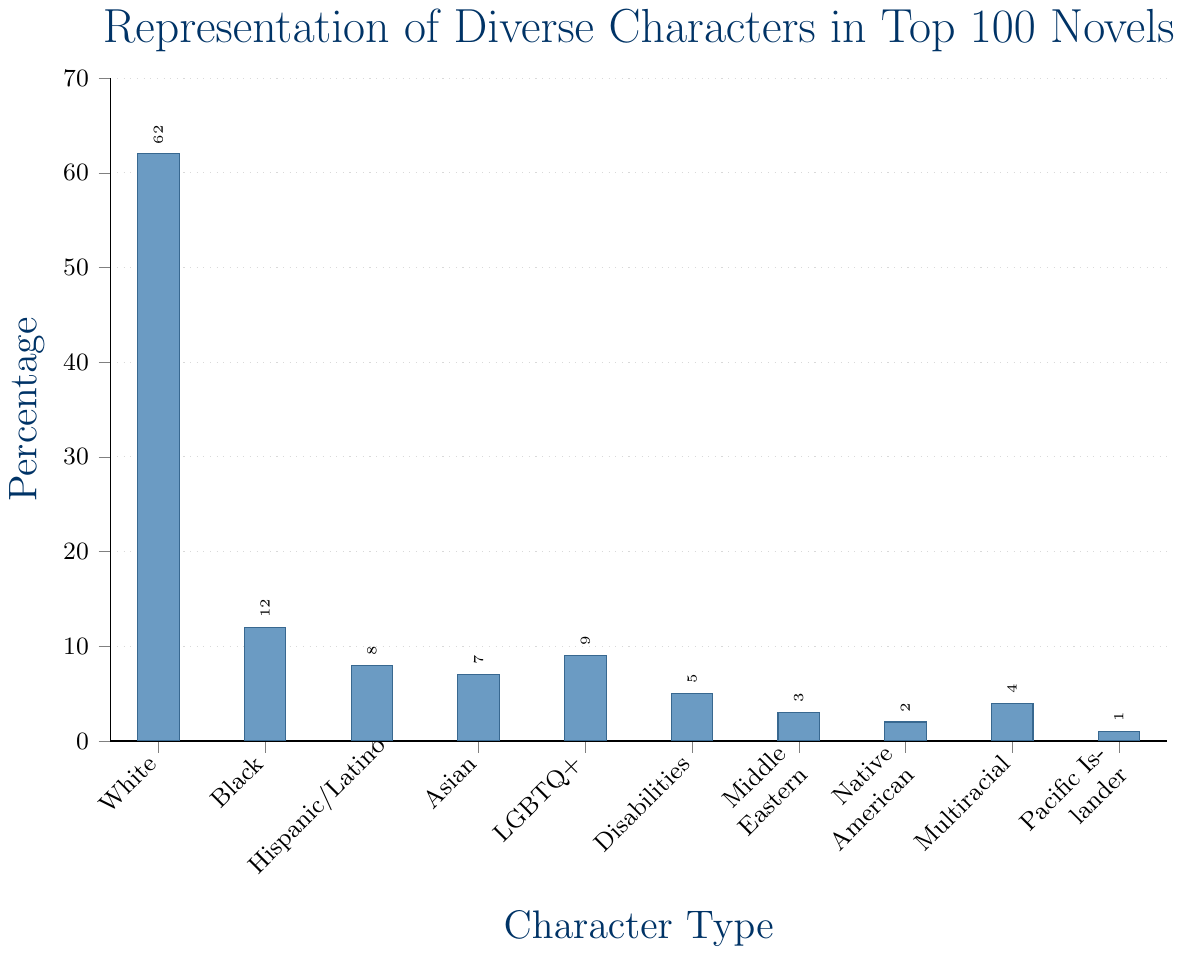What's the total percentage of characters that are either Hispanic/Latino or Asian? The chart shows the percentage of Hispanic/Latino Characters is 8 and the percentage of Asian Characters is 7. Adding these percentages together: 8 + 7 = 15
Answer: 15 Which character type has the smallest representation, and what is its percentage? The chart shows that Pacific Islander Characters have the smallest representation with a percentage of 1.
Answer: Pacific Islander Characters: 1 What is the difference in percentage between White Characters and Black Characters? The percentage of White Characters is 62 and the percentage of Black Characters is 12. Subtracting the percentage of Black Characters from White Characters: 62 - 12 = 50
Answer: 50 How many character types have a percentage representation of at least 5? By examining the bar heights, the character types with at least 5% representation are: White Characters (62), Black Characters (12), Hispanic/Latino Characters (8), Asian Characters (7), LGBTQ+ Characters (9), and Characters with Disabilities (5). This makes 6 character types.
Answer: 6 What percentage of characters are non-White (not including White Characters)? The chart shows the percentages for each character type. Summing them all except White Characters: 12 (Black) + 8 (Hispanic/Latino) + 7 (Asian) + 9 (LGBTQ+) + 5 (Disabilities) + 3 (Middle Eastern) + 2 (Native American) + 4 (Multiracial) + 1 (Pacific Islander) = 51
Answer: 51 Are there more Hispanic/Latino Characters or LGBTQ+ Characters, and by how much? The chart shows the percentage of Hispanic/Latino Characters is 8 and the percentage of LGBTQ+ Characters is 9. Comparing the two, there is 1% more LGBTQ+ Characters than Hispanic/Latino Characters: 9 - 8 = 1
Answer: LGBTQ+ Characters by 1 Which two character types together have a representation equal to that of LGBTQ+ Characters? The chart shows that Native American Characters have 2% and Middle Eastern Characters have 3%. Summing these percentages: 2 + 3 = 5 is not equal to 9 (LGBTQ+ Characters). Native American Characters (2) plus Multiracial Characters (4): 2 + 4 = 6 is not equal. Given Asian Characters 7% + Multiracial Characters 4%: 7 + 4 = 11 is not correct. However, Hispanic/Latino (8) and Pacific Islander (1) together: 8 + 1 = 9 which equal to LGBTQ+ Characters.
Answer: Hispanic/Latino and Pacific Islander What is the average percentage of representation for Black, Asian, and Hispanic/Latino Characters? The percentages are Black: 12, Asian: 7, and Hispanic/Latino: 8. Sum these values: 12 + 7 + 8 = 27. Then divide by 3 (number of categories): 27 / 3 = 9
Answer: 9 What percentage gap exists between the second most represented character type and the third most represented character type? The second most represented character type is Black Characters with 12% and the third most represented character type is LGBTQ+ Characters with 9%. The gap is calculated as: 12 - 9 = 3
Answer: 3 